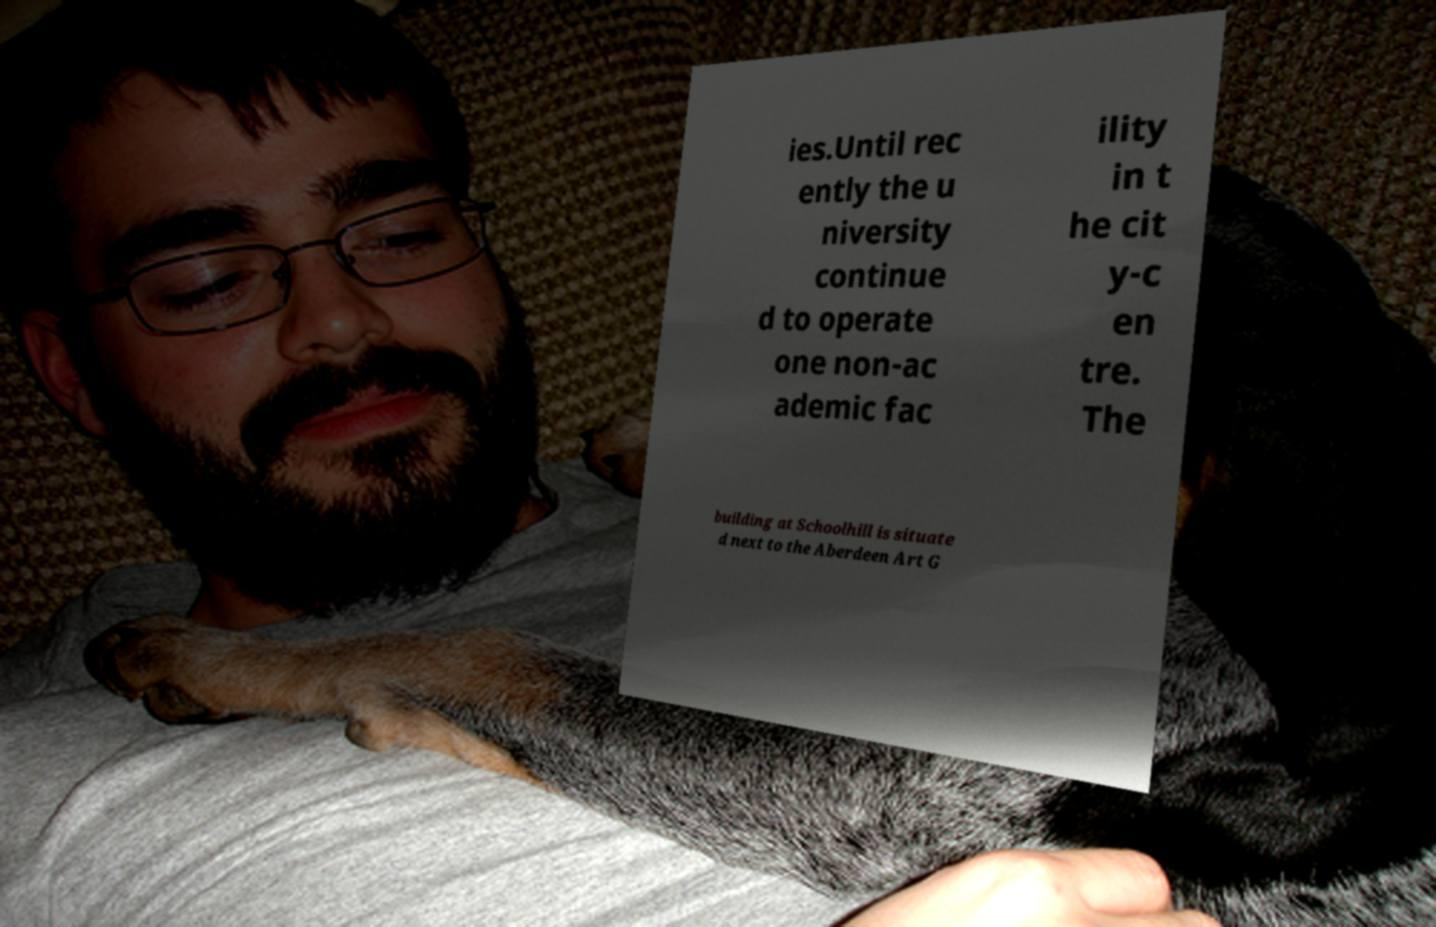Can you read and provide the text displayed in the image?This photo seems to have some interesting text. Can you extract and type it out for me? ies.Until rec ently the u niversity continue d to operate one non-ac ademic fac ility in t he cit y-c en tre. The building at Schoolhill is situate d next to the Aberdeen Art G 